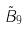Convert formula to latex. <formula><loc_0><loc_0><loc_500><loc_500>\tilde { B } _ { 9 }</formula> 